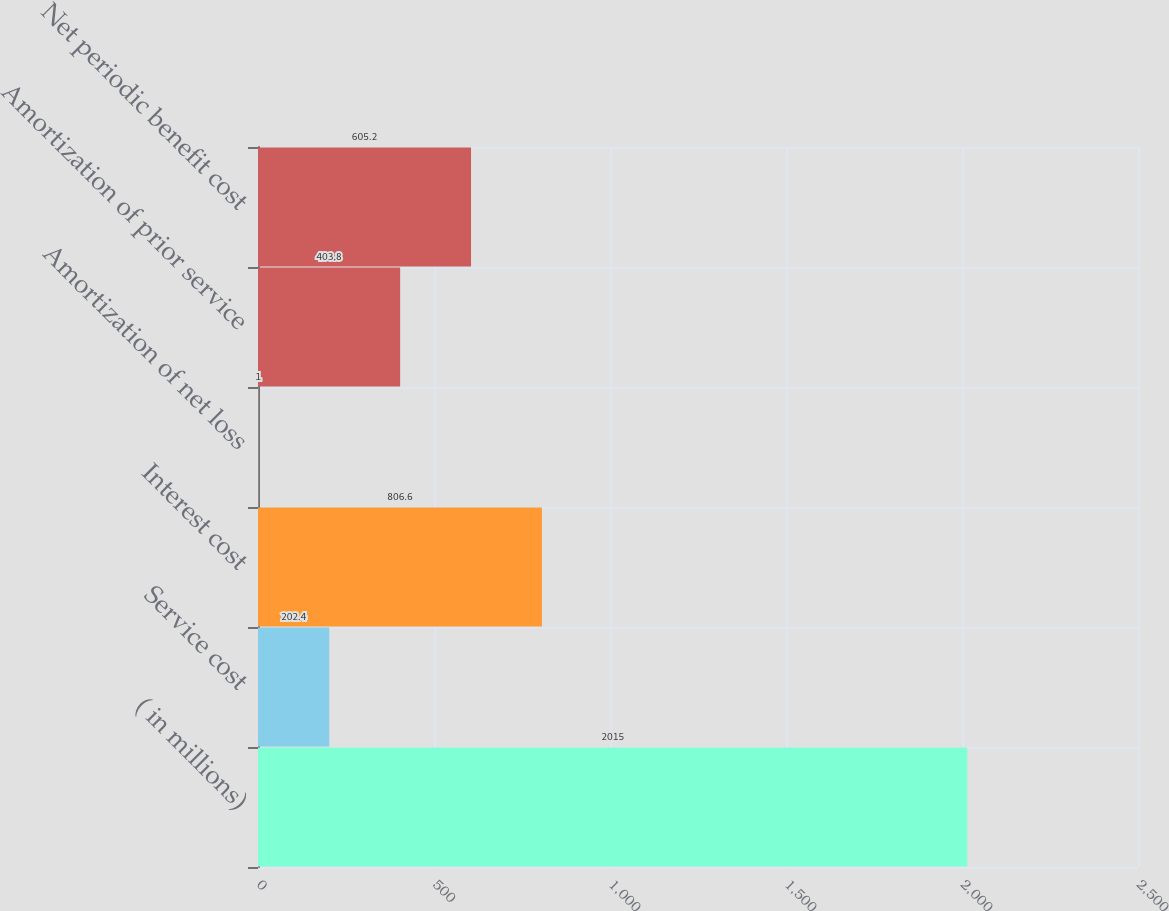Convert chart to OTSL. <chart><loc_0><loc_0><loc_500><loc_500><bar_chart><fcel>( in millions)<fcel>Service cost<fcel>Interest cost<fcel>Amortization of net loss<fcel>Amortization of prior service<fcel>Net periodic benefit cost<nl><fcel>2015<fcel>202.4<fcel>806.6<fcel>1<fcel>403.8<fcel>605.2<nl></chart> 